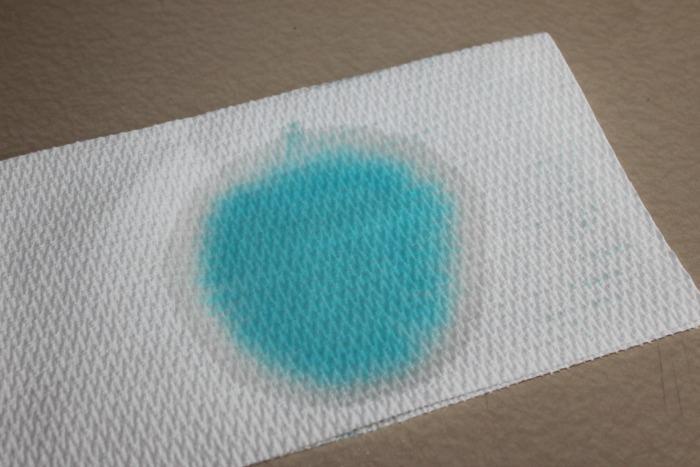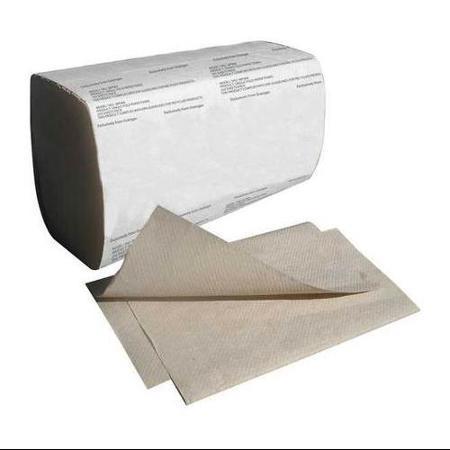The first image is the image on the left, the second image is the image on the right. Analyze the images presented: Is the assertion "A human hand is partially visible in the right image." valid? Answer yes or no. No. The first image is the image on the left, the second image is the image on the right. Evaluate the accuracy of this statement regarding the images: "The image on the left shows a human hand grabbing the edge of a paper towel.". Is it true? Answer yes or no. No. 